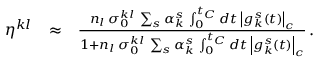Convert formula to latex. <formula><loc_0><loc_0><loc_500><loc_500>\begin{array} { r l r } { \eta ^ { k l } } & { \approx } & { \frac { n _ { l } \, \sigma _ { 0 } ^ { k l } \, \sum _ { s } \alpha _ { k } ^ { s } \, \int _ { 0 } ^ { t _ { C } } d t \, \left | g _ { k } ^ { s } ( t ) \right | _ { c } } { 1 + n _ { l } \, \sigma _ { 0 } ^ { k l } \, \sum _ { s } \alpha _ { k } ^ { s } \, \int _ { 0 } ^ { t _ { C } } d t \, \left | g _ { k } ^ { s } ( t ) \right | _ { c } } \, . } \end{array}</formula> 